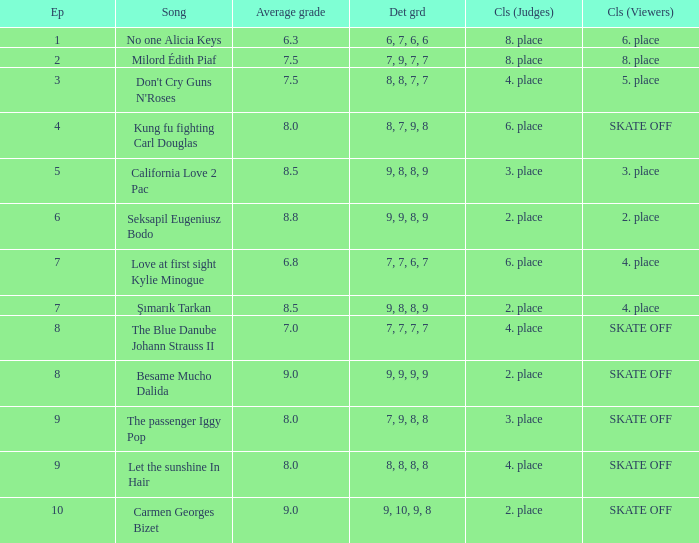Name the average grade for şımarık tarkan 8.5. 